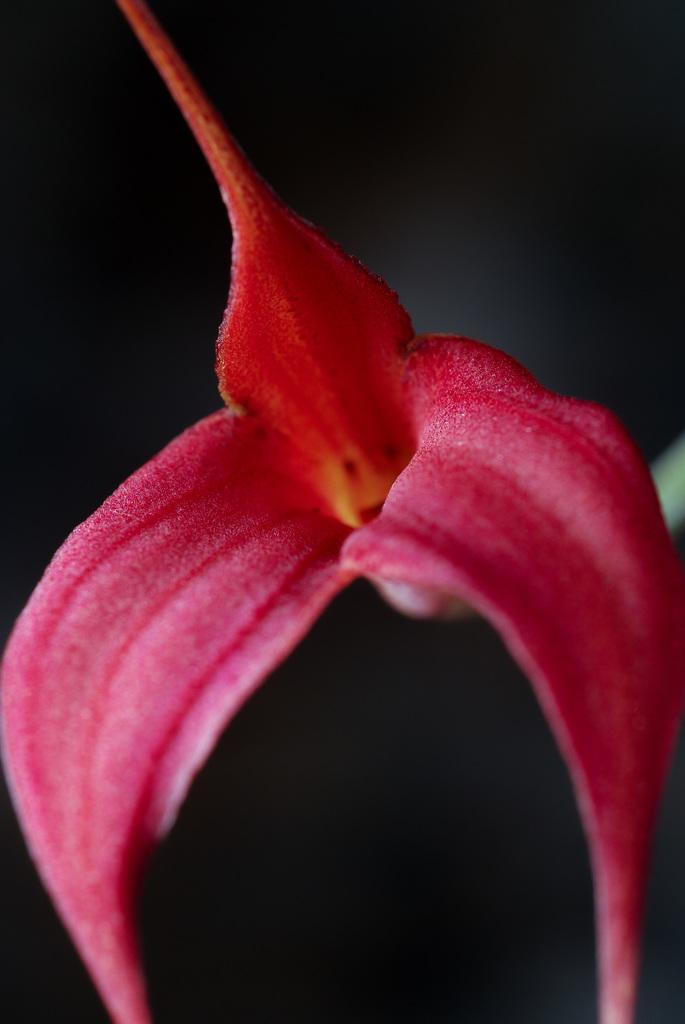What type of flower is present in the image? There is a pink color flower in the image. What can be observed about the background of the image? The background of the image is dark. What shape is the basin in the image? There is no basin present in the image. How many rays are emanating from the circle in the image? There is no circle or rays present in the image. 